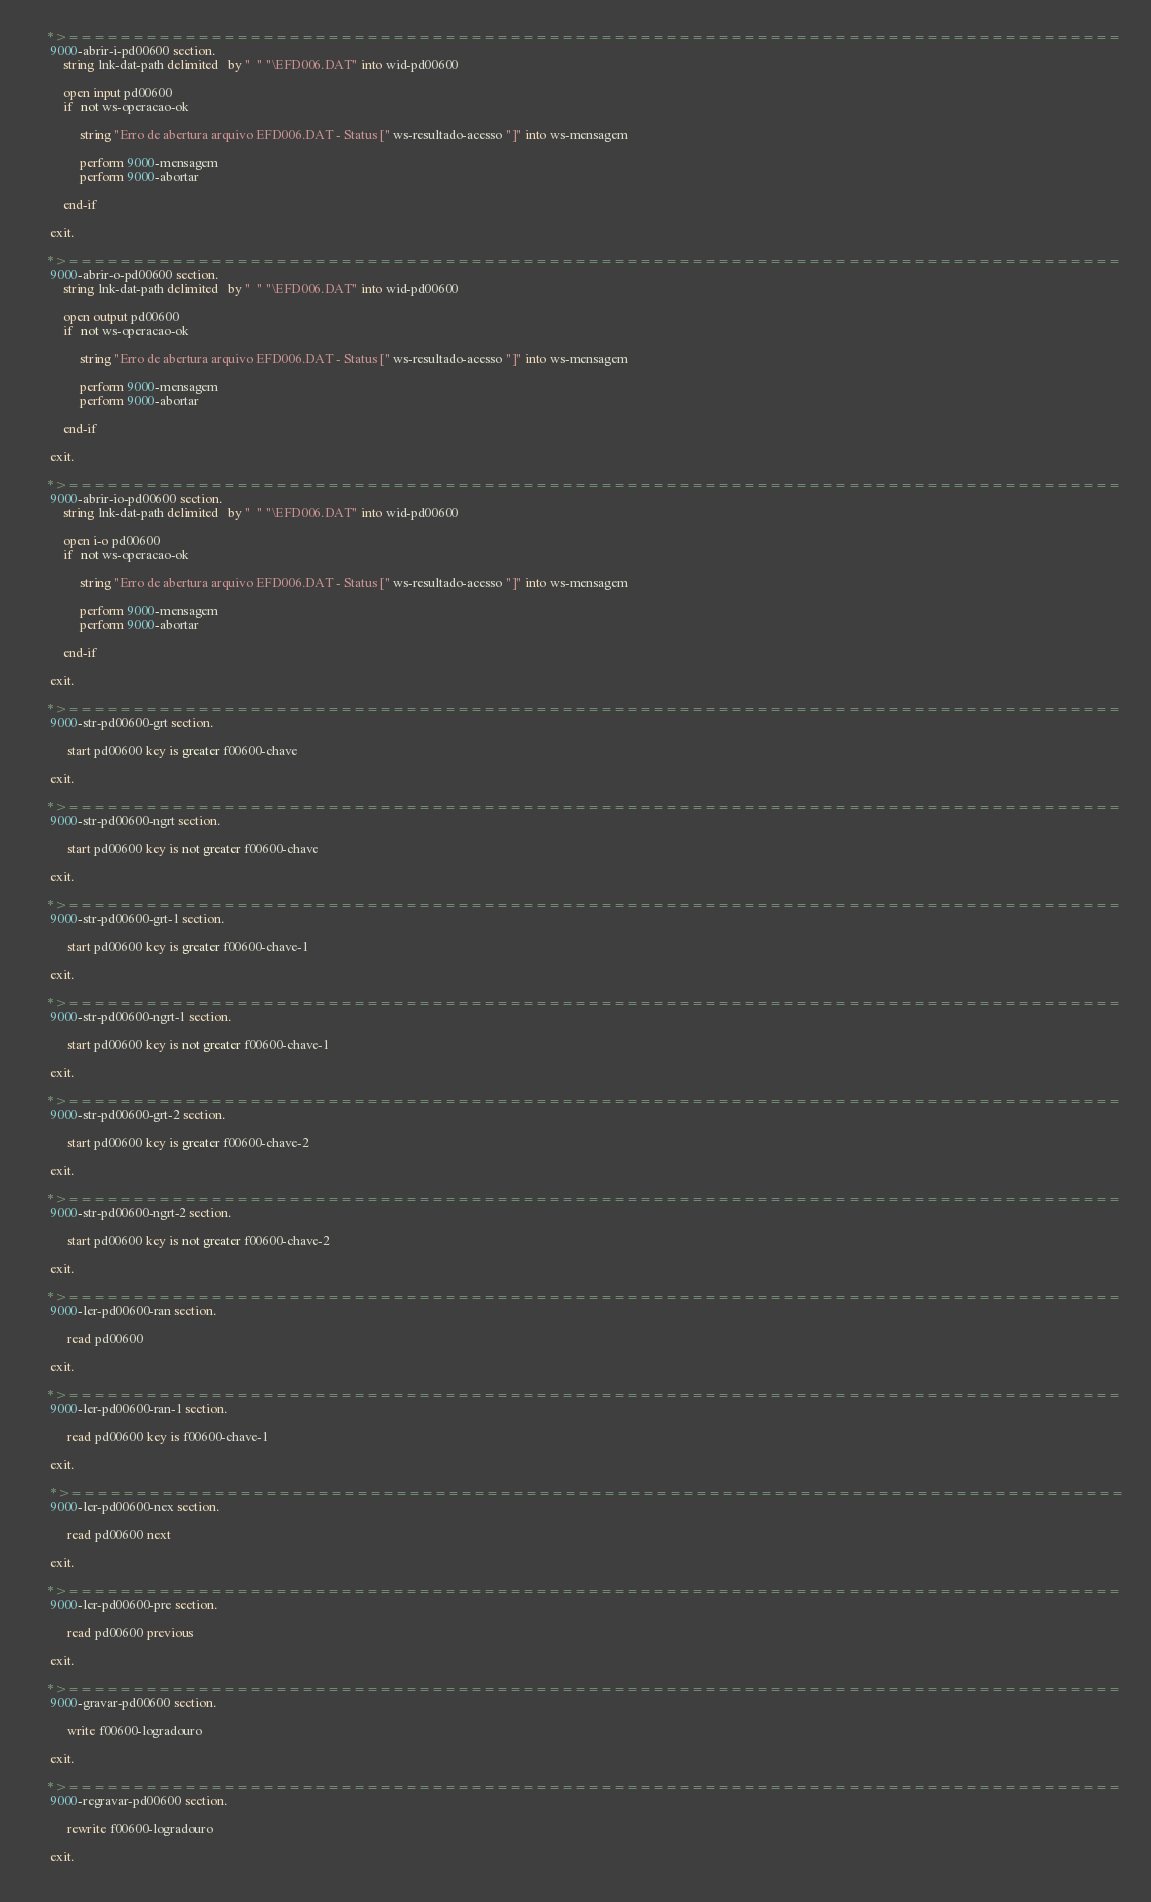<code> <loc_0><loc_0><loc_500><loc_500><_COBOL_>      *>================================================================================= 
       9000-abrir-i-pd00600 section.
           string lnk-dat-path delimited   by "  " "\EFD006.DAT" into wid-pd00600                             
                                           
           open input pd00600
           if   not ws-operacao-ok
                
                string "Erro de abertura arquivo EFD006.DAT - Status [" ws-resultado-acesso "]" into ws-mensagem
                
                perform 9000-mensagem
                perform 9000-abortar

           end-if
           
       exit.
       
      *>================================================================================= 
       9000-abrir-o-pd00600 section.
           string lnk-dat-path delimited   by "  " "\EFD006.DAT" into wid-pd00600                             
                                           
           open output pd00600
           if   not ws-operacao-ok
                
                string "Erro de abertura arquivo EFD006.DAT - Status [" ws-resultado-acesso "]" into ws-mensagem
                
                perform 9000-mensagem
                perform 9000-abortar

           end-if
           
       exit.

      *>================================================================================= 
       9000-abrir-io-pd00600 section.
           string lnk-dat-path delimited   by "  " "\EFD006.DAT" into wid-pd00600                             
                                           
           open i-o pd00600
           if   not ws-operacao-ok
                
                string "Erro de abertura arquivo EFD006.DAT - Status [" ws-resultado-acesso "]" into ws-mensagem
                
                perform 9000-mensagem
                perform 9000-abortar

           end-if
           
       exit.

      *>=================================================================================
       9000-str-pd00600-grt section.
       
            start pd00600 key is greater f00600-chave
       
       exit.

      *>=================================================================================
       9000-str-pd00600-ngrt section.
       
            start pd00600 key is not greater f00600-chave
       
       exit.

      *>=================================================================================
       9000-str-pd00600-grt-1 section.
       
            start pd00600 key is greater f00600-chave-1
       
       exit.

      *>=================================================================================
       9000-str-pd00600-ngrt-1 section.
       
            start pd00600 key is not greater f00600-chave-1
       
       exit.

      *>=================================================================================
       9000-str-pd00600-grt-2 section.
       
            start pd00600 key is greater f00600-chave-2
       
       exit.

      *>=================================================================================
       9000-str-pd00600-ngrt-2 section.
       
            start pd00600 key is not greater f00600-chave-2
       
       exit.       
       
      *>=================================================================================
       9000-ler-pd00600-ran section.
       
            read pd00600
       
       exit. 

      *>=================================================================================
       9000-ler-pd00600-ran-1 section.
       
            read pd00600 key is f00600-chave-1
       
       exit.
        
       *>=================================================================================
       9000-ler-pd00600-nex section.
       
            read pd00600 next
       
       exit. 
             
      *>=================================================================================
       9000-ler-pd00600-pre section.
       
            read pd00600 previous
       
       exit.              
             
      *>=================================================================================
       9000-gravar-pd00600 section.
       
            write f00600-logradouro
           
       exit.
       
      *>=================================================================================
       9000-regravar-pd00600 section.
       
            rewrite f00600-logradouro
           
       exit.
     </code> 